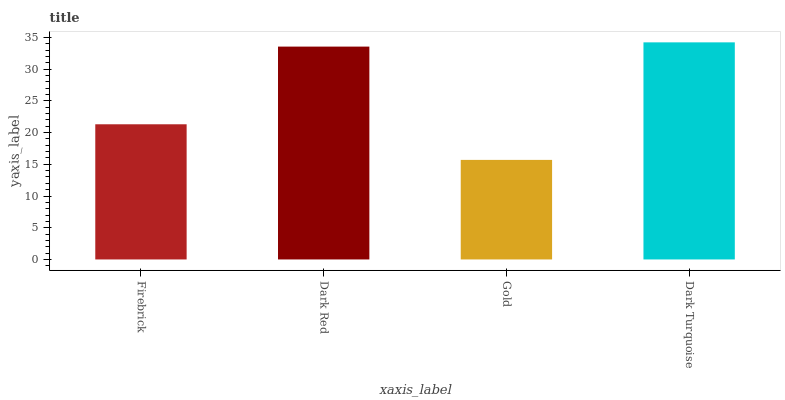Is Dark Turquoise the maximum?
Answer yes or no. Yes. Is Dark Red the minimum?
Answer yes or no. No. Is Dark Red the maximum?
Answer yes or no. No. Is Dark Red greater than Firebrick?
Answer yes or no. Yes. Is Firebrick less than Dark Red?
Answer yes or no. Yes. Is Firebrick greater than Dark Red?
Answer yes or no. No. Is Dark Red less than Firebrick?
Answer yes or no. No. Is Dark Red the high median?
Answer yes or no. Yes. Is Firebrick the low median?
Answer yes or no. Yes. Is Firebrick the high median?
Answer yes or no. No. Is Dark Turquoise the low median?
Answer yes or no. No. 